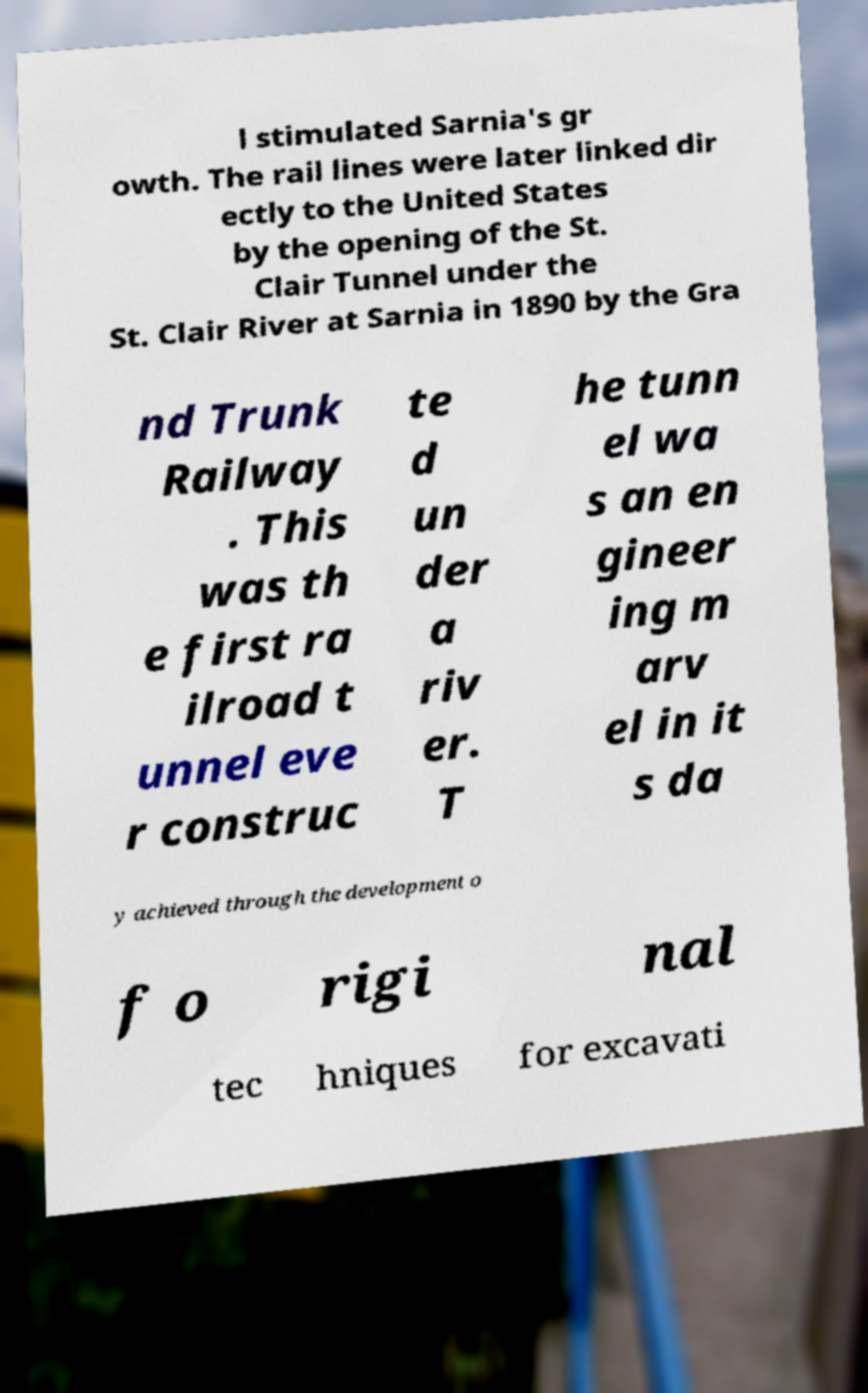I need the written content from this picture converted into text. Can you do that? l stimulated Sarnia's gr owth. The rail lines were later linked dir ectly to the United States by the opening of the St. Clair Tunnel under the St. Clair River at Sarnia in 1890 by the Gra nd Trunk Railway . This was th e first ra ilroad t unnel eve r construc te d un der a riv er. T he tunn el wa s an en gineer ing m arv el in it s da y achieved through the development o f o rigi nal tec hniques for excavati 